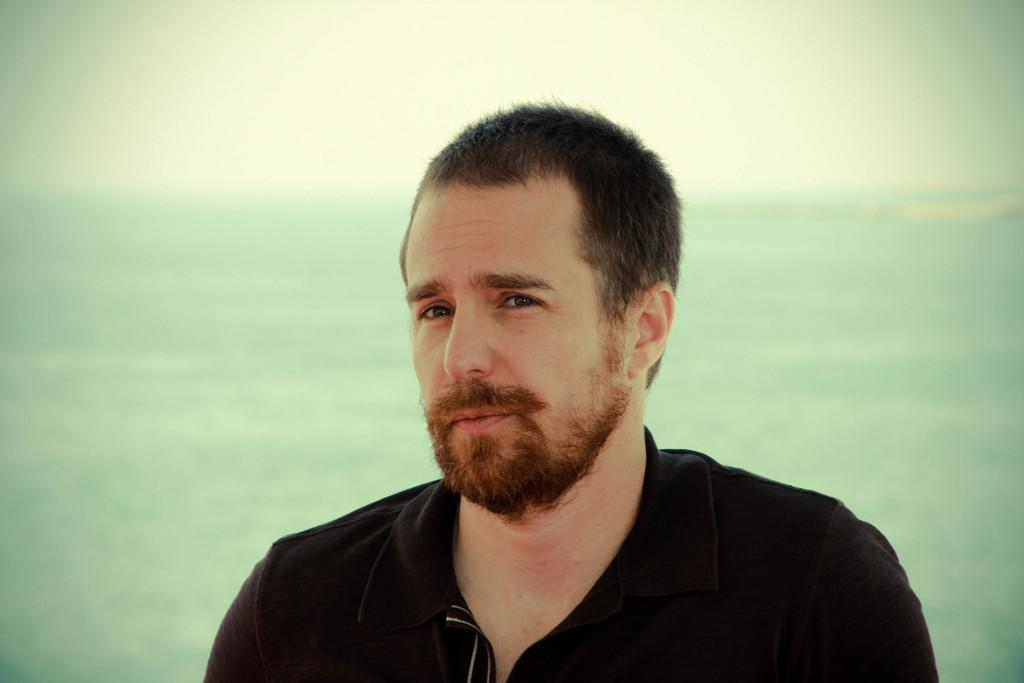Who or what is the main subject in the image? There is a person in the image. What is the person wearing? The person is wearing a black colored dress. Can you describe the background of the image? The background of the image is cream and green in color. What type of pen is the person holding in the image? There is no pen visible in the image. What is the person's tendency towards a particular activity in the image? The image does not provide any information about the person's tendencies or preferences. 